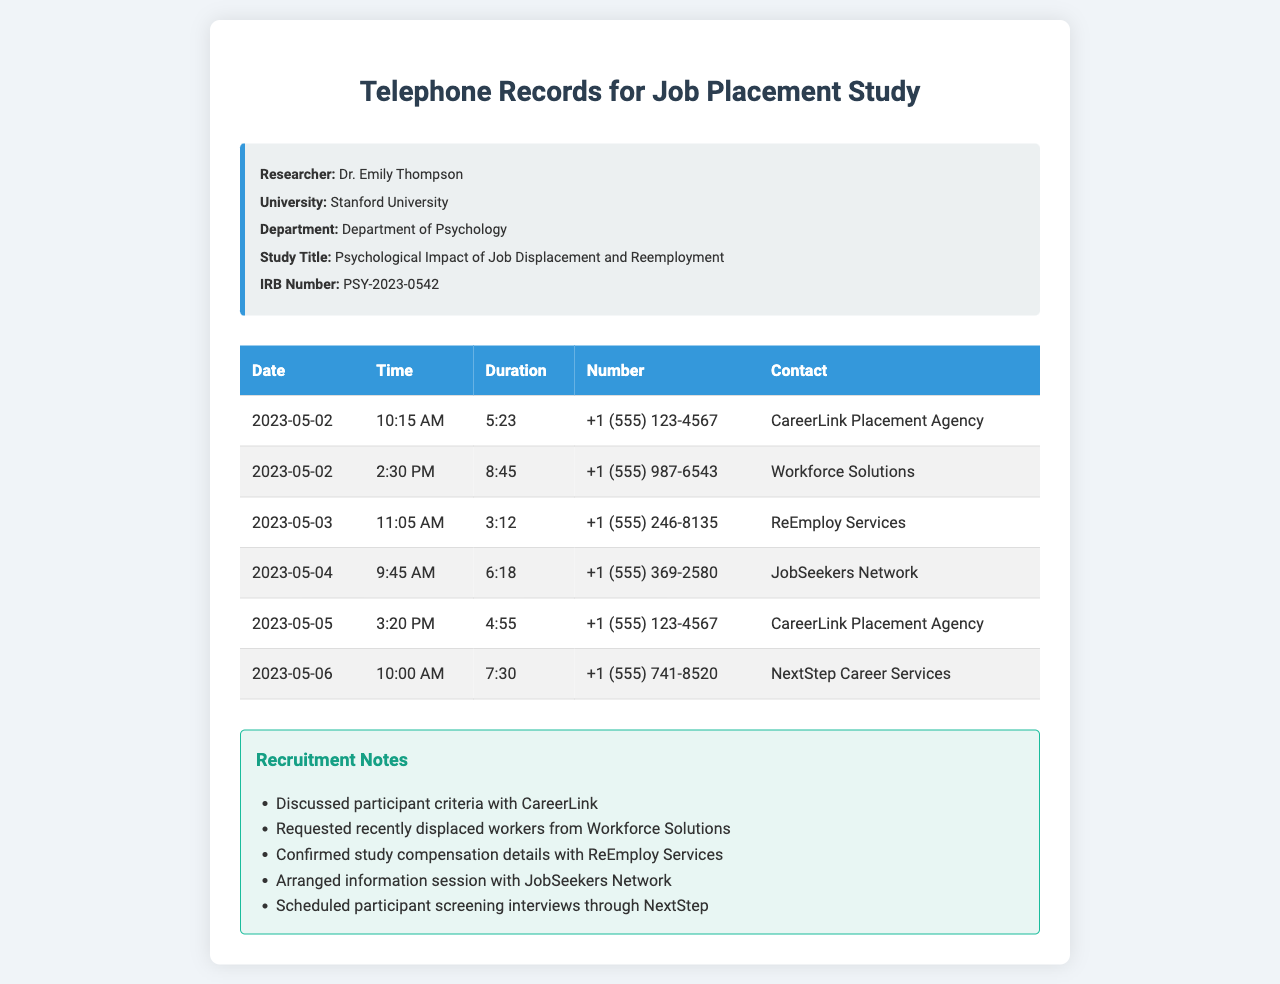What is the IRB number for the study? The IRB number is listed in the study information section of the document.
Answer: PSY-2023-0542 Who conducted the study? The researcher’s name is provided in the study information section.
Answer: Dr. Emily Thompson What is the name of the placement agency contacted on May 2nd at 10:15 AM? The details of the contacts are listed in the telephone records table.
Answer: CareerLink Placement Agency How long was the call with Workforce Solutions on May 2nd? The duration of the call is specified in the telephone records table.
Answer: 8:45 How many calls were made to CareerLink Placement Agency? The number of calls can be determined from counting the rows associated with CareerLink in the table.
Answer: 2 What date was the call with NextStep Career Services? The date of the call is provided in the telephone records table.
Answer: May 6 What was discussed with CareerLink, according to the recruitment notes? The notes section provides information about discussions for recruitment.
Answer: Participant criteria What information was requested from Workforce Solutions? Information about requests is specified in the recruitment notes section.
Answer: Recently displaced workers Which agency arranged participant screening interviews? The recruitment notes indicate which agency arranged the interviews.
Answer: NextStep Career Services 